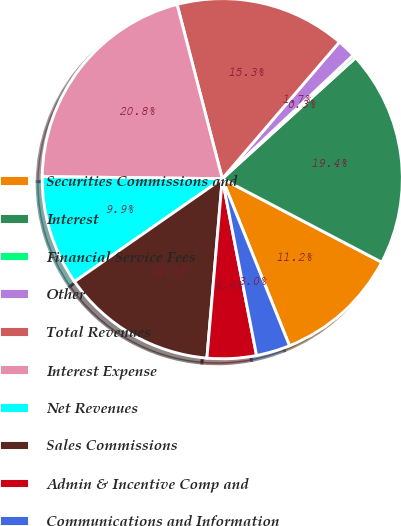<chart> <loc_0><loc_0><loc_500><loc_500><pie_chart><fcel>Securities Commissions and<fcel>Interest<fcel>Financial Service Fees<fcel>Other<fcel>Total Revenues<fcel>Interest Expense<fcel>Net Revenues<fcel>Sales Commissions<fcel>Admin & Incentive Comp and<fcel>Communications and Information<nl><fcel>11.23%<fcel>19.41%<fcel>0.31%<fcel>1.68%<fcel>15.32%<fcel>20.78%<fcel>9.86%<fcel>13.96%<fcel>4.41%<fcel>3.04%<nl></chart> 